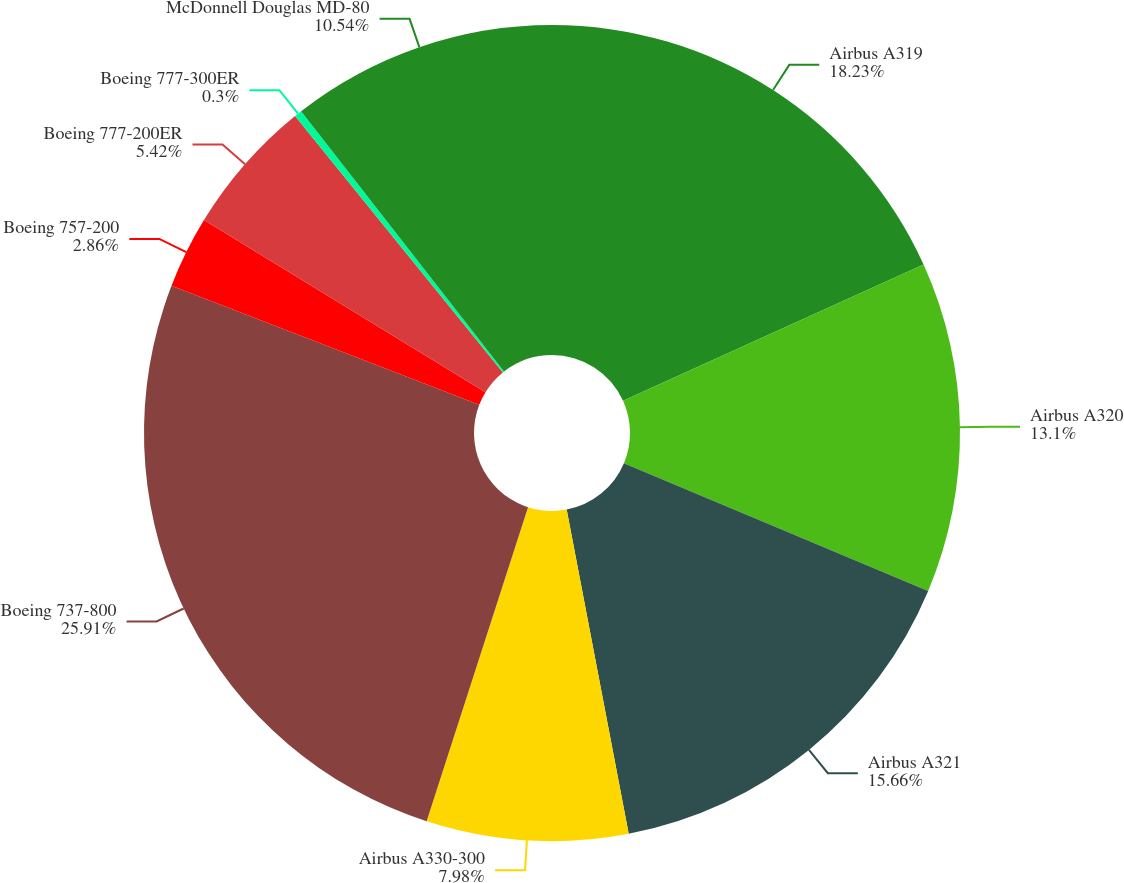<chart> <loc_0><loc_0><loc_500><loc_500><pie_chart><fcel>Airbus A319<fcel>Airbus A320<fcel>Airbus A321<fcel>Airbus A330-300<fcel>Boeing 737-800<fcel>Boeing 757-200<fcel>Boeing 777-200ER<fcel>Boeing 777-300ER<fcel>McDonnell Douglas MD-80<nl><fcel>18.22%<fcel>13.1%<fcel>15.66%<fcel>7.98%<fcel>25.9%<fcel>2.86%<fcel>5.42%<fcel>0.3%<fcel>10.54%<nl></chart> 